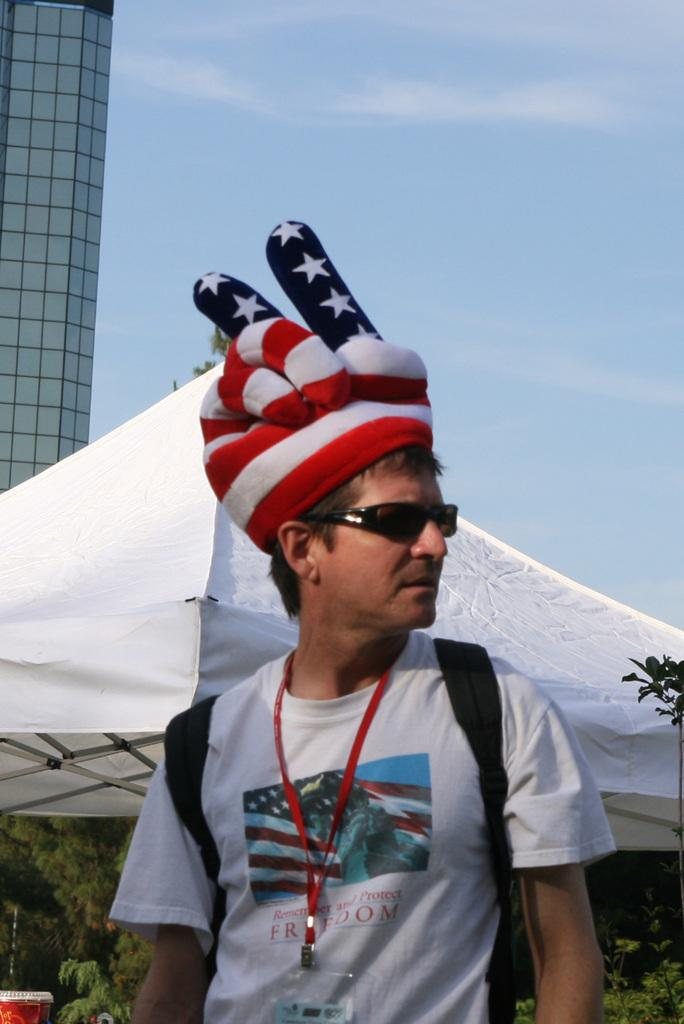What is the main subject of the image? There is a man in the image. What is the man wearing on his head? The man is wearing a cap. What is the man wearing to protect his eyes? The man is wearing goggles. Is there any identification or labeling on the man? Yes, the man has a tag. What can be seen in the background of the image? There is a tent, trees, a building, and the sky visible in the background of the image. How does the man pull the trick on the holiday in the image? There is no mention of a trick or a holiday in the image, so this question cannot be answered. 